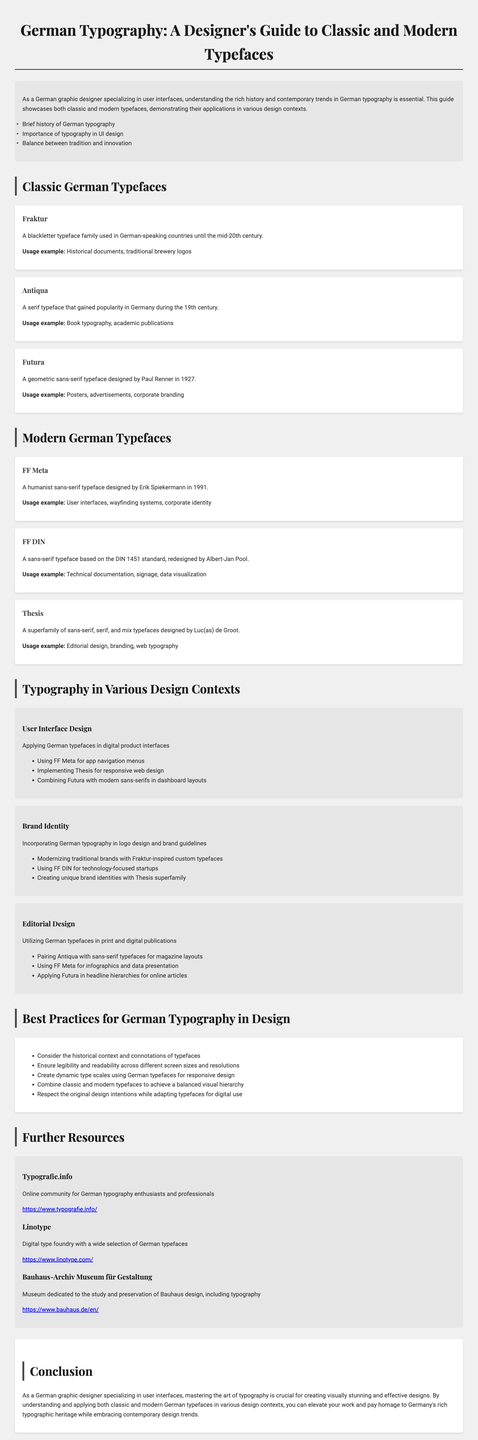What is the title of the brochure? The title of the brochure is found at the top of the document.
Answer: German Typography: A Designer's Guide to Classic and Modern Typefaces How many classic typefaces are showcased? The number of classic typefaces is listed in the "Classic German Typefaces" section.
Answer: Three Who designed Futura? The designer's name is mentioned in the description of Futura in the classic typefaces section.
Answer: Paul Renner What design context features user interfaces? The design context names are listed under "Typography in Various Design Contexts."
Answer: User Interface Design What is one best practice mentioned for German typography? The best practices are listed in the "Best Practices for German Typography in Design" section.
Answer: Ensure legibility and readability across different screen sizes and resolutions What year was FF Meta designed? The year of design for FF Meta is provided in the description of that typeface.
Answer: 1991 What online community is suggested for typography enthusiasts? The resources section lists different resources including online communities.
Answer: Typografie.info What typeface is recommended for technical documentation? This is found in the usage examples under modern typefaces.
Answer: FF DIN 